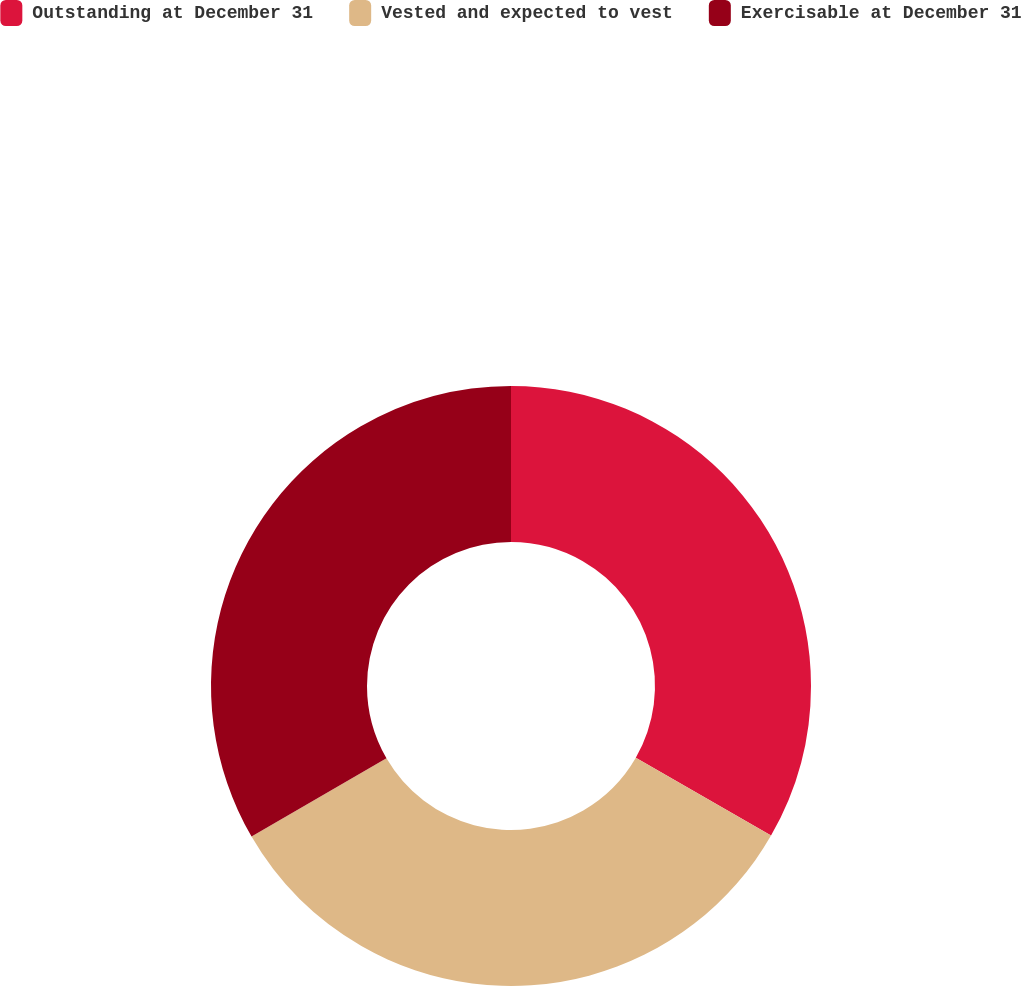<chart> <loc_0><loc_0><loc_500><loc_500><pie_chart><fcel>Outstanding at December 31<fcel>Vested and expected to vest<fcel>Exercisable at December 31<nl><fcel>33.31%<fcel>33.32%<fcel>33.37%<nl></chart> 